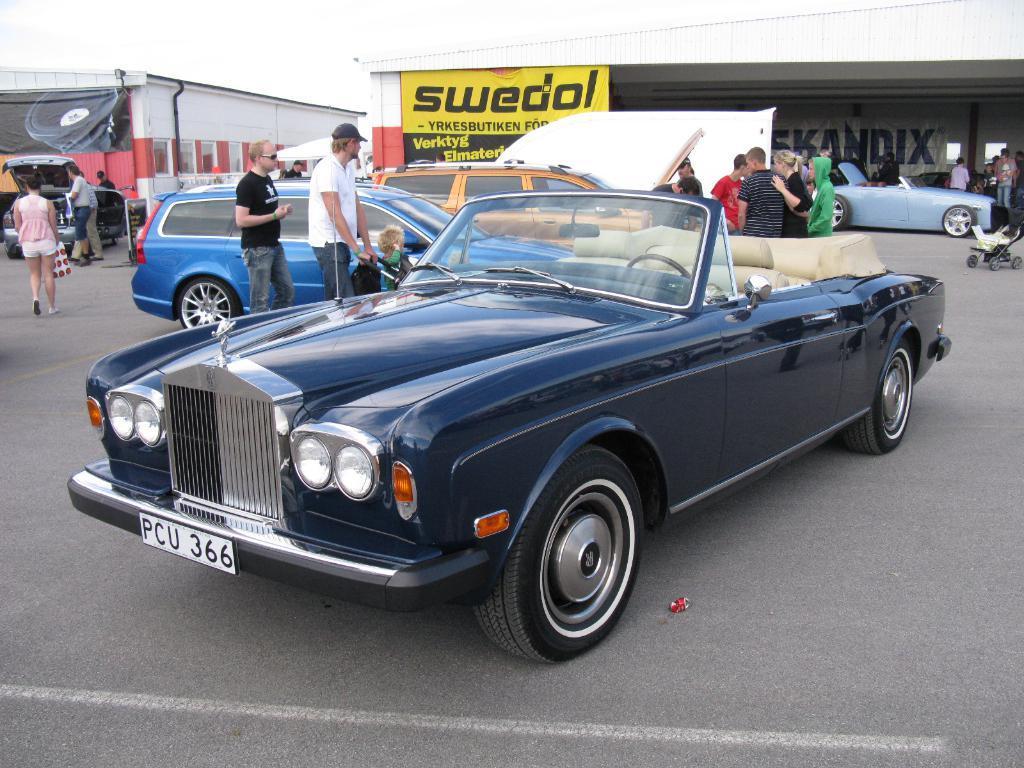In one or two sentences, can you explain what this image depicts? This picture is clicked outside. In the center we can see the group of cars seems to be parked on the ground and we can see the group of persons and there are some objects placed on the ground. In the background we can see the sky and the buildings and there is a yellow color board on which we can see the text and we can see the text on the wall of a building. 